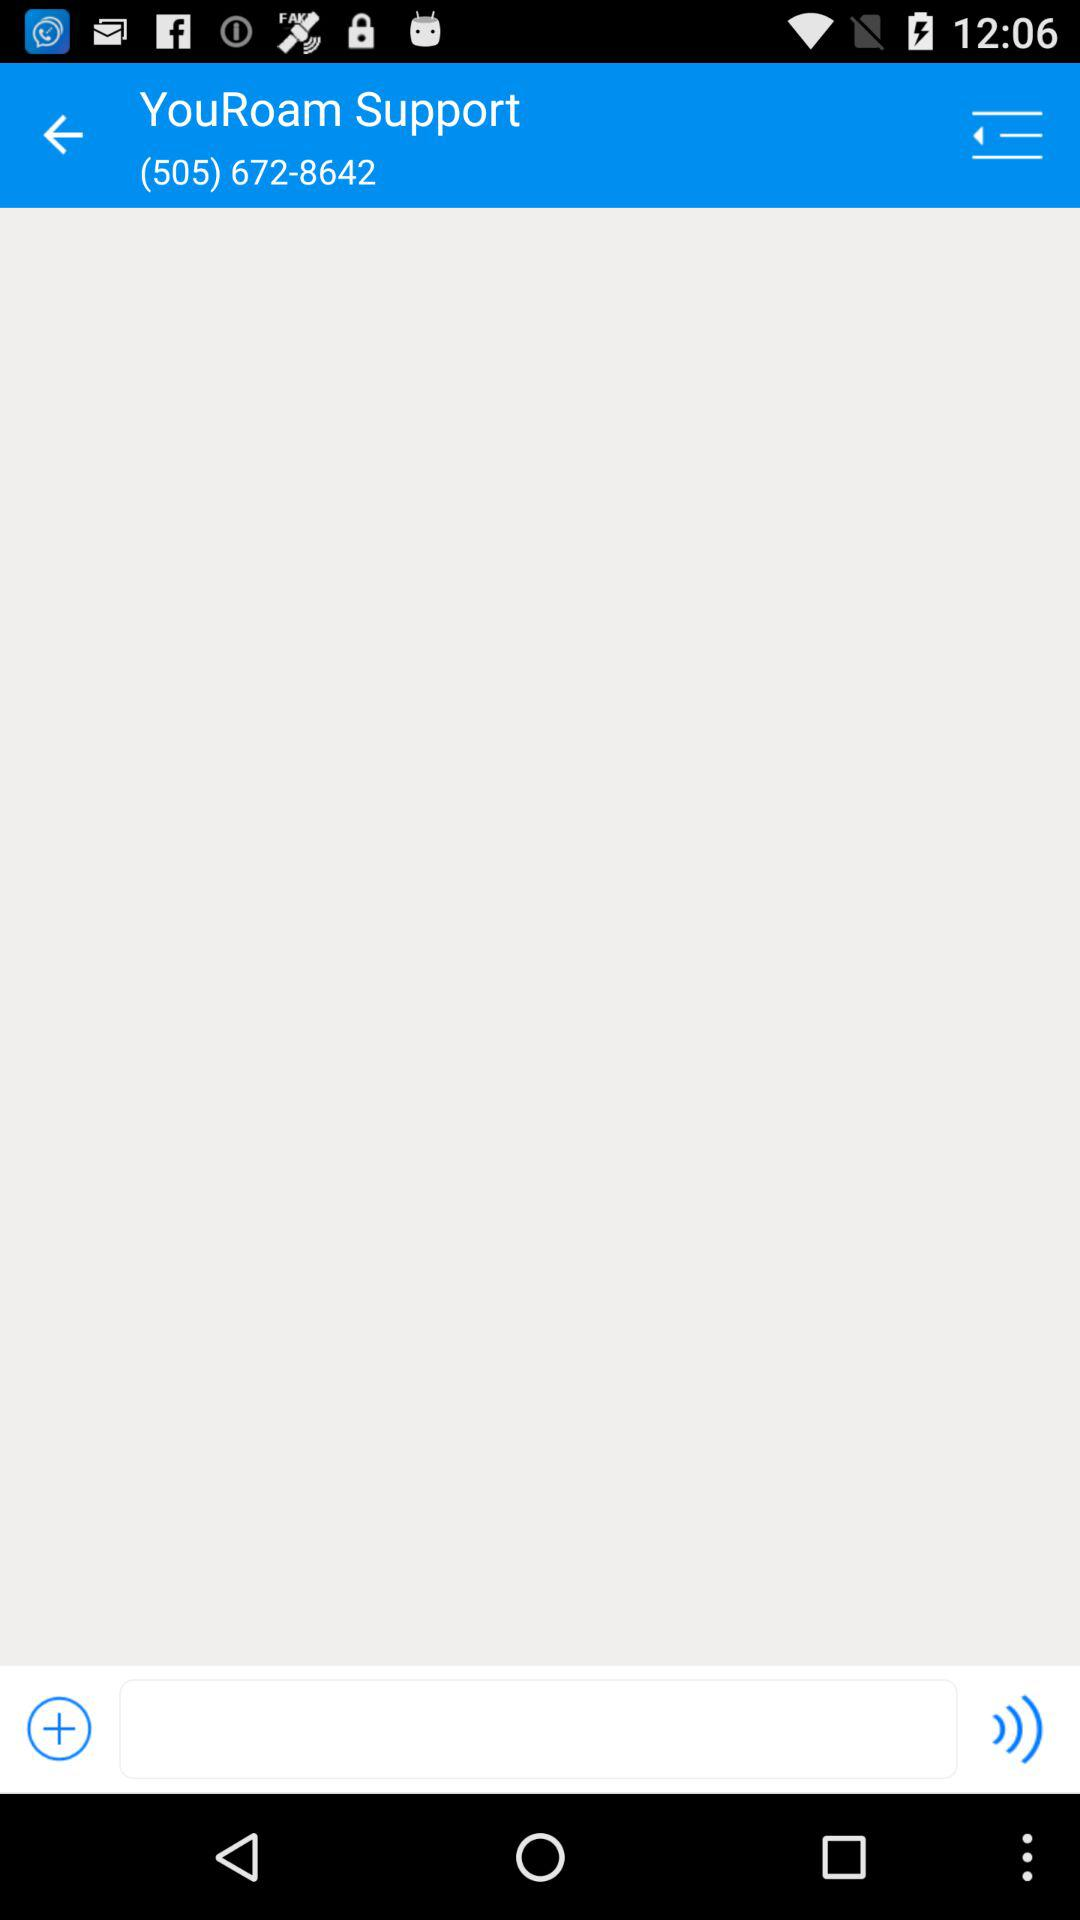What is the contact number given? The contact number is (505) 672-8642. 